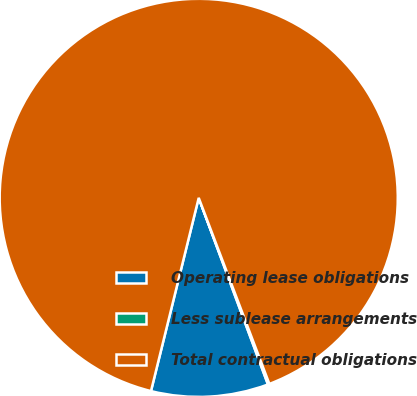<chart> <loc_0><loc_0><loc_500><loc_500><pie_chart><fcel>Operating lease obligations<fcel>Less sublease arrangements<fcel>Total contractual obligations<nl><fcel>9.51%<fcel>0.12%<fcel>90.36%<nl></chart> 